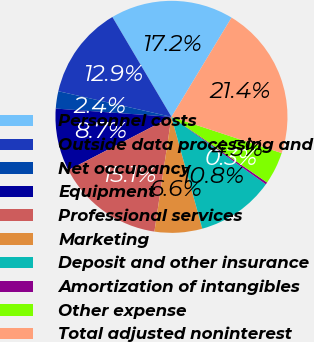Convert chart. <chart><loc_0><loc_0><loc_500><loc_500><pie_chart><fcel>Personnel costs<fcel>Outside data processing and<fcel>Net occupancy<fcel>Equipment<fcel>Professional services<fcel>Marketing<fcel>Deposit and other insurance<fcel>Amortization of intangibles<fcel>Other expense<fcel>Total adjusted noninterest<nl><fcel>17.17%<fcel>12.95%<fcel>2.41%<fcel>8.73%<fcel>15.06%<fcel>6.63%<fcel>10.84%<fcel>0.3%<fcel>4.52%<fcel>21.39%<nl></chart> 